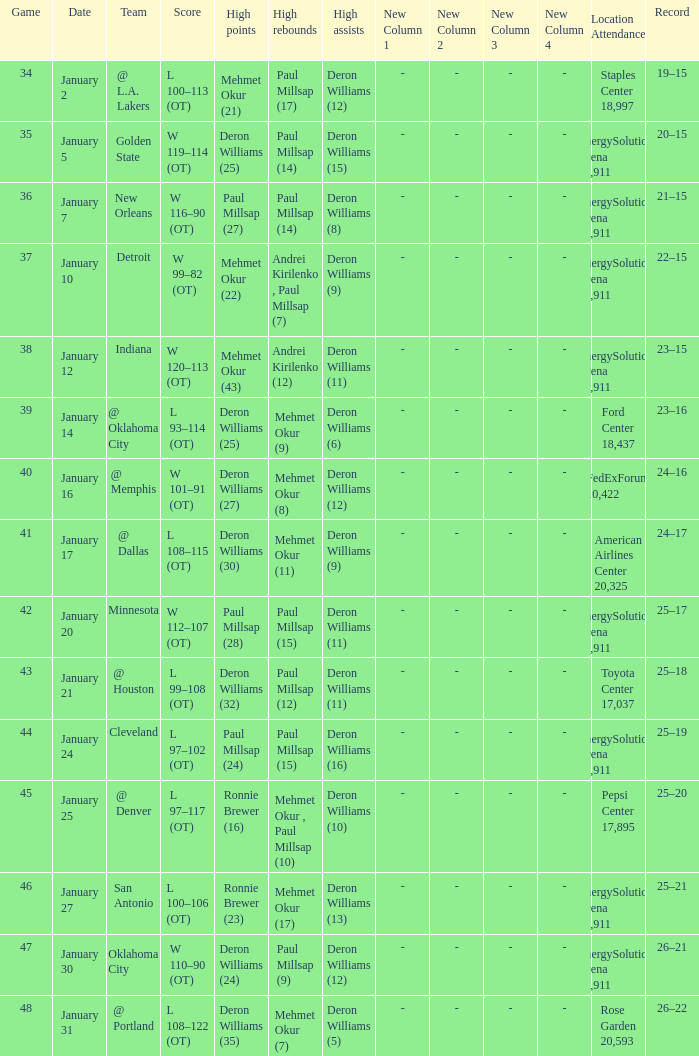Who had the high rebounds of the game that Deron Williams (5) had the high assists? Mehmet Okur (7). 